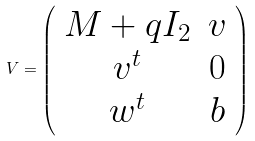<formula> <loc_0><loc_0><loc_500><loc_500>V = \left ( \begin{array} { c c } M + q I _ { 2 } & v \\ v ^ { t } & 0 \\ w ^ { t } & b \end{array} \right )</formula> 